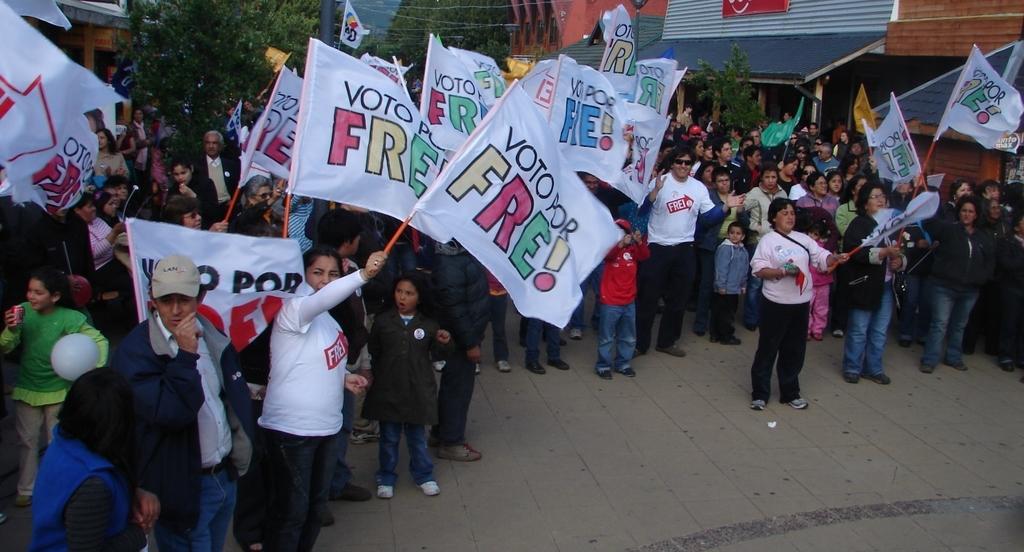Please provide a concise description of this image. A group of people standing in the group,A lady is holding a flag,A person is speaking to a lady, A group of houses in a row, there are tree in the image. 